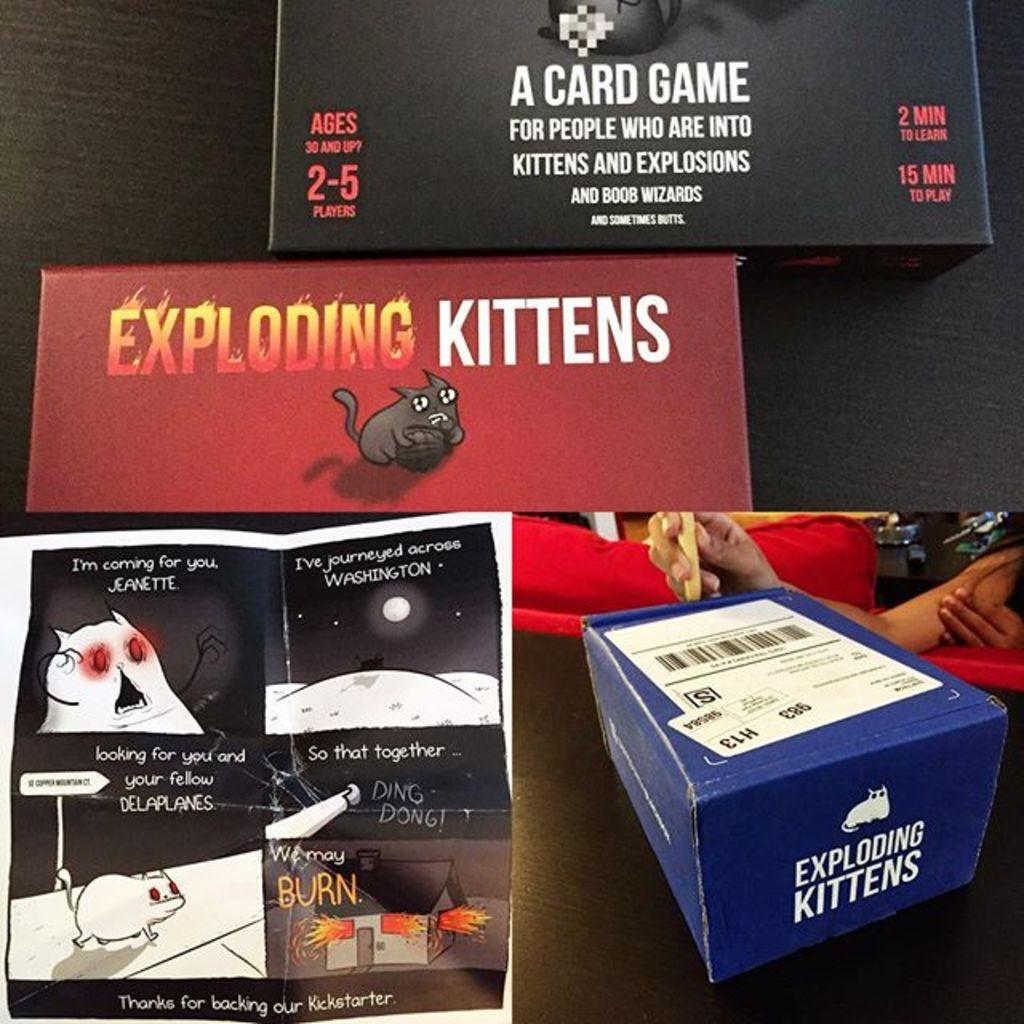<image>
Offer a succinct explanation of the picture presented. a collage of photos with one that has a box labeled 'exploding kittens' 